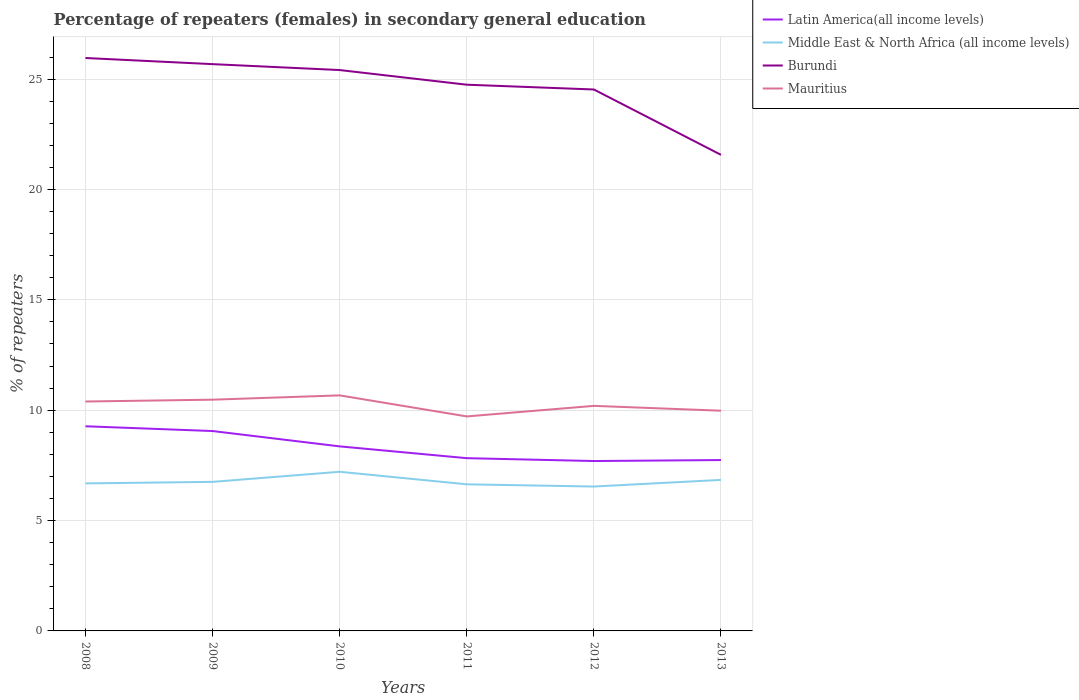Does the line corresponding to Middle East & North Africa (all income levels) intersect with the line corresponding to Latin America(all income levels)?
Offer a terse response. No. Across all years, what is the maximum percentage of female repeaters in Mauritius?
Keep it short and to the point. 9.72. What is the total percentage of female repeaters in Middle East & North Africa (all income levels) in the graph?
Provide a short and direct response. -0.53. What is the difference between the highest and the second highest percentage of female repeaters in Burundi?
Provide a short and direct response. 4.39. Is the percentage of female repeaters in Burundi strictly greater than the percentage of female repeaters in Mauritius over the years?
Your answer should be compact. No. How many lines are there?
Offer a very short reply. 4. What is the difference between two consecutive major ticks on the Y-axis?
Your response must be concise. 5. Are the values on the major ticks of Y-axis written in scientific E-notation?
Provide a succinct answer. No. Where does the legend appear in the graph?
Your response must be concise. Top right. How are the legend labels stacked?
Provide a succinct answer. Vertical. What is the title of the graph?
Offer a very short reply. Percentage of repeaters (females) in secondary general education. Does "Cote d'Ivoire" appear as one of the legend labels in the graph?
Make the answer very short. No. What is the label or title of the X-axis?
Make the answer very short. Years. What is the label or title of the Y-axis?
Make the answer very short. % of repeaters. What is the % of repeaters in Latin America(all income levels) in 2008?
Give a very brief answer. 9.27. What is the % of repeaters of Middle East & North Africa (all income levels) in 2008?
Your response must be concise. 6.68. What is the % of repeaters of Burundi in 2008?
Ensure brevity in your answer.  25.96. What is the % of repeaters in Mauritius in 2008?
Offer a terse response. 10.39. What is the % of repeaters in Latin America(all income levels) in 2009?
Ensure brevity in your answer.  9.06. What is the % of repeaters of Middle East & North Africa (all income levels) in 2009?
Offer a terse response. 6.75. What is the % of repeaters in Burundi in 2009?
Offer a terse response. 25.68. What is the % of repeaters in Mauritius in 2009?
Ensure brevity in your answer.  10.48. What is the % of repeaters in Latin America(all income levels) in 2010?
Provide a succinct answer. 8.36. What is the % of repeaters in Middle East & North Africa (all income levels) in 2010?
Provide a succinct answer. 7.21. What is the % of repeaters of Burundi in 2010?
Make the answer very short. 25.41. What is the % of repeaters in Mauritius in 2010?
Offer a very short reply. 10.67. What is the % of repeaters in Latin America(all income levels) in 2011?
Give a very brief answer. 7.83. What is the % of repeaters of Middle East & North Africa (all income levels) in 2011?
Your answer should be compact. 6.64. What is the % of repeaters in Burundi in 2011?
Give a very brief answer. 24.75. What is the % of repeaters of Mauritius in 2011?
Offer a terse response. 9.72. What is the % of repeaters of Latin America(all income levels) in 2012?
Offer a very short reply. 7.7. What is the % of repeaters in Middle East & North Africa (all income levels) in 2012?
Provide a succinct answer. 6.54. What is the % of repeaters of Burundi in 2012?
Your answer should be compact. 24.53. What is the % of repeaters in Mauritius in 2012?
Your answer should be compact. 10.2. What is the % of repeaters of Latin America(all income levels) in 2013?
Ensure brevity in your answer.  7.74. What is the % of repeaters of Middle East & North Africa (all income levels) in 2013?
Provide a succinct answer. 6.84. What is the % of repeaters in Burundi in 2013?
Make the answer very short. 21.57. What is the % of repeaters in Mauritius in 2013?
Offer a terse response. 9.98. Across all years, what is the maximum % of repeaters of Latin America(all income levels)?
Your response must be concise. 9.27. Across all years, what is the maximum % of repeaters of Middle East & North Africa (all income levels)?
Give a very brief answer. 7.21. Across all years, what is the maximum % of repeaters in Burundi?
Offer a very short reply. 25.96. Across all years, what is the maximum % of repeaters of Mauritius?
Keep it short and to the point. 10.67. Across all years, what is the minimum % of repeaters in Latin America(all income levels)?
Your response must be concise. 7.7. Across all years, what is the minimum % of repeaters of Middle East & North Africa (all income levels)?
Your answer should be compact. 6.54. Across all years, what is the minimum % of repeaters of Burundi?
Make the answer very short. 21.57. Across all years, what is the minimum % of repeaters of Mauritius?
Offer a terse response. 9.72. What is the total % of repeaters in Latin America(all income levels) in the graph?
Offer a terse response. 49.96. What is the total % of repeaters of Middle East & North Africa (all income levels) in the graph?
Ensure brevity in your answer.  40.68. What is the total % of repeaters in Burundi in the graph?
Provide a succinct answer. 147.9. What is the total % of repeaters in Mauritius in the graph?
Ensure brevity in your answer.  61.44. What is the difference between the % of repeaters of Latin America(all income levels) in 2008 and that in 2009?
Offer a very short reply. 0.22. What is the difference between the % of repeaters of Middle East & North Africa (all income levels) in 2008 and that in 2009?
Give a very brief answer. -0.07. What is the difference between the % of repeaters in Burundi in 2008 and that in 2009?
Offer a terse response. 0.28. What is the difference between the % of repeaters in Mauritius in 2008 and that in 2009?
Keep it short and to the point. -0.08. What is the difference between the % of repeaters of Latin America(all income levels) in 2008 and that in 2010?
Make the answer very short. 0.91. What is the difference between the % of repeaters in Middle East & North Africa (all income levels) in 2008 and that in 2010?
Offer a very short reply. -0.53. What is the difference between the % of repeaters in Burundi in 2008 and that in 2010?
Your answer should be very brief. 0.55. What is the difference between the % of repeaters in Mauritius in 2008 and that in 2010?
Your answer should be very brief. -0.28. What is the difference between the % of repeaters in Latin America(all income levels) in 2008 and that in 2011?
Provide a succinct answer. 1.45. What is the difference between the % of repeaters of Middle East & North Africa (all income levels) in 2008 and that in 2011?
Your answer should be compact. 0.04. What is the difference between the % of repeaters of Burundi in 2008 and that in 2011?
Make the answer very short. 1.21. What is the difference between the % of repeaters of Mauritius in 2008 and that in 2011?
Your answer should be compact. 0.68. What is the difference between the % of repeaters of Latin America(all income levels) in 2008 and that in 2012?
Your answer should be compact. 1.57. What is the difference between the % of repeaters of Middle East & North Africa (all income levels) in 2008 and that in 2012?
Keep it short and to the point. 0.14. What is the difference between the % of repeaters in Burundi in 2008 and that in 2012?
Offer a very short reply. 1.43. What is the difference between the % of repeaters of Mauritius in 2008 and that in 2012?
Offer a terse response. 0.2. What is the difference between the % of repeaters in Latin America(all income levels) in 2008 and that in 2013?
Ensure brevity in your answer.  1.53. What is the difference between the % of repeaters in Middle East & North Africa (all income levels) in 2008 and that in 2013?
Offer a terse response. -0.16. What is the difference between the % of repeaters of Burundi in 2008 and that in 2013?
Offer a very short reply. 4.39. What is the difference between the % of repeaters in Mauritius in 2008 and that in 2013?
Make the answer very short. 0.42. What is the difference between the % of repeaters in Latin America(all income levels) in 2009 and that in 2010?
Make the answer very short. 0.69. What is the difference between the % of repeaters in Middle East & North Africa (all income levels) in 2009 and that in 2010?
Your answer should be very brief. -0.46. What is the difference between the % of repeaters of Burundi in 2009 and that in 2010?
Give a very brief answer. 0.27. What is the difference between the % of repeaters in Mauritius in 2009 and that in 2010?
Offer a very short reply. -0.19. What is the difference between the % of repeaters of Latin America(all income levels) in 2009 and that in 2011?
Give a very brief answer. 1.23. What is the difference between the % of repeaters of Middle East & North Africa (all income levels) in 2009 and that in 2011?
Ensure brevity in your answer.  0.11. What is the difference between the % of repeaters in Burundi in 2009 and that in 2011?
Offer a very short reply. 0.93. What is the difference between the % of repeaters of Mauritius in 2009 and that in 2011?
Provide a short and direct response. 0.76. What is the difference between the % of repeaters of Latin America(all income levels) in 2009 and that in 2012?
Offer a terse response. 1.36. What is the difference between the % of repeaters of Middle East & North Africa (all income levels) in 2009 and that in 2012?
Your answer should be compact. 0.21. What is the difference between the % of repeaters in Burundi in 2009 and that in 2012?
Make the answer very short. 1.15. What is the difference between the % of repeaters of Mauritius in 2009 and that in 2012?
Your answer should be compact. 0.28. What is the difference between the % of repeaters of Latin America(all income levels) in 2009 and that in 2013?
Make the answer very short. 1.31. What is the difference between the % of repeaters of Middle East & North Africa (all income levels) in 2009 and that in 2013?
Provide a short and direct response. -0.09. What is the difference between the % of repeaters in Burundi in 2009 and that in 2013?
Provide a succinct answer. 4.11. What is the difference between the % of repeaters of Mauritius in 2009 and that in 2013?
Give a very brief answer. 0.5. What is the difference between the % of repeaters of Latin America(all income levels) in 2010 and that in 2011?
Make the answer very short. 0.53. What is the difference between the % of repeaters of Middle East & North Africa (all income levels) in 2010 and that in 2011?
Ensure brevity in your answer.  0.57. What is the difference between the % of repeaters in Burundi in 2010 and that in 2011?
Your answer should be very brief. 0.66. What is the difference between the % of repeaters in Mauritius in 2010 and that in 2011?
Your response must be concise. 0.95. What is the difference between the % of repeaters in Latin America(all income levels) in 2010 and that in 2012?
Provide a succinct answer. 0.66. What is the difference between the % of repeaters in Middle East & North Africa (all income levels) in 2010 and that in 2012?
Your answer should be compact. 0.67. What is the difference between the % of repeaters in Burundi in 2010 and that in 2012?
Ensure brevity in your answer.  0.88. What is the difference between the % of repeaters of Mauritius in 2010 and that in 2012?
Make the answer very short. 0.48. What is the difference between the % of repeaters of Latin America(all income levels) in 2010 and that in 2013?
Your answer should be compact. 0.62. What is the difference between the % of repeaters in Middle East & North Africa (all income levels) in 2010 and that in 2013?
Provide a short and direct response. 0.37. What is the difference between the % of repeaters of Burundi in 2010 and that in 2013?
Offer a very short reply. 3.84. What is the difference between the % of repeaters of Mauritius in 2010 and that in 2013?
Keep it short and to the point. 0.69. What is the difference between the % of repeaters in Latin America(all income levels) in 2011 and that in 2012?
Offer a very short reply. 0.13. What is the difference between the % of repeaters in Middle East & North Africa (all income levels) in 2011 and that in 2012?
Offer a very short reply. 0.1. What is the difference between the % of repeaters of Burundi in 2011 and that in 2012?
Ensure brevity in your answer.  0.22. What is the difference between the % of repeaters of Mauritius in 2011 and that in 2012?
Keep it short and to the point. -0.48. What is the difference between the % of repeaters of Latin America(all income levels) in 2011 and that in 2013?
Provide a short and direct response. 0.08. What is the difference between the % of repeaters of Middle East & North Africa (all income levels) in 2011 and that in 2013?
Give a very brief answer. -0.2. What is the difference between the % of repeaters of Burundi in 2011 and that in 2013?
Offer a very short reply. 3.18. What is the difference between the % of repeaters in Mauritius in 2011 and that in 2013?
Provide a short and direct response. -0.26. What is the difference between the % of repeaters of Latin America(all income levels) in 2012 and that in 2013?
Give a very brief answer. -0.04. What is the difference between the % of repeaters in Middle East & North Africa (all income levels) in 2012 and that in 2013?
Keep it short and to the point. -0.3. What is the difference between the % of repeaters of Burundi in 2012 and that in 2013?
Offer a terse response. 2.96. What is the difference between the % of repeaters in Mauritius in 2012 and that in 2013?
Your response must be concise. 0.22. What is the difference between the % of repeaters in Latin America(all income levels) in 2008 and the % of repeaters in Middle East & North Africa (all income levels) in 2009?
Provide a succinct answer. 2.52. What is the difference between the % of repeaters of Latin America(all income levels) in 2008 and the % of repeaters of Burundi in 2009?
Offer a terse response. -16.41. What is the difference between the % of repeaters of Latin America(all income levels) in 2008 and the % of repeaters of Mauritius in 2009?
Your response must be concise. -1.2. What is the difference between the % of repeaters of Middle East & North Africa (all income levels) in 2008 and the % of repeaters of Burundi in 2009?
Provide a succinct answer. -19. What is the difference between the % of repeaters of Middle East & North Africa (all income levels) in 2008 and the % of repeaters of Mauritius in 2009?
Make the answer very short. -3.79. What is the difference between the % of repeaters in Burundi in 2008 and the % of repeaters in Mauritius in 2009?
Offer a terse response. 15.48. What is the difference between the % of repeaters of Latin America(all income levels) in 2008 and the % of repeaters of Middle East & North Africa (all income levels) in 2010?
Provide a succinct answer. 2.06. What is the difference between the % of repeaters in Latin America(all income levels) in 2008 and the % of repeaters in Burundi in 2010?
Your answer should be compact. -16.14. What is the difference between the % of repeaters of Latin America(all income levels) in 2008 and the % of repeaters of Mauritius in 2010?
Provide a short and direct response. -1.4. What is the difference between the % of repeaters in Middle East & North Africa (all income levels) in 2008 and the % of repeaters in Burundi in 2010?
Your answer should be very brief. -18.73. What is the difference between the % of repeaters of Middle East & North Africa (all income levels) in 2008 and the % of repeaters of Mauritius in 2010?
Your response must be concise. -3.99. What is the difference between the % of repeaters in Burundi in 2008 and the % of repeaters in Mauritius in 2010?
Make the answer very short. 15.29. What is the difference between the % of repeaters of Latin America(all income levels) in 2008 and the % of repeaters of Middle East & North Africa (all income levels) in 2011?
Your answer should be compact. 2.63. What is the difference between the % of repeaters of Latin America(all income levels) in 2008 and the % of repeaters of Burundi in 2011?
Your answer should be very brief. -15.48. What is the difference between the % of repeaters of Latin America(all income levels) in 2008 and the % of repeaters of Mauritius in 2011?
Keep it short and to the point. -0.45. What is the difference between the % of repeaters of Middle East & North Africa (all income levels) in 2008 and the % of repeaters of Burundi in 2011?
Provide a succinct answer. -18.06. What is the difference between the % of repeaters in Middle East & North Africa (all income levels) in 2008 and the % of repeaters in Mauritius in 2011?
Provide a short and direct response. -3.04. What is the difference between the % of repeaters of Burundi in 2008 and the % of repeaters of Mauritius in 2011?
Your answer should be very brief. 16.24. What is the difference between the % of repeaters of Latin America(all income levels) in 2008 and the % of repeaters of Middle East & North Africa (all income levels) in 2012?
Offer a terse response. 2.73. What is the difference between the % of repeaters in Latin America(all income levels) in 2008 and the % of repeaters in Burundi in 2012?
Make the answer very short. -15.26. What is the difference between the % of repeaters in Latin America(all income levels) in 2008 and the % of repeaters in Mauritius in 2012?
Offer a very short reply. -0.92. What is the difference between the % of repeaters of Middle East & North Africa (all income levels) in 2008 and the % of repeaters of Burundi in 2012?
Provide a succinct answer. -17.85. What is the difference between the % of repeaters of Middle East & North Africa (all income levels) in 2008 and the % of repeaters of Mauritius in 2012?
Provide a succinct answer. -3.51. What is the difference between the % of repeaters in Burundi in 2008 and the % of repeaters in Mauritius in 2012?
Your response must be concise. 15.76. What is the difference between the % of repeaters in Latin America(all income levels) in 2008 and the % of repeaters in Middle East & North Africa (all income levels) in 2013?
Offer a terse response. 2.43. What is the difference between the % of repeaters in Latin America(all income levels) in 2008 and the % of repeaters in Burundi in 2013?
Your response must be concise. -12.3. What is the difference between the % of repeaters of Latin America(all income levels) in 2008 and the % of repeaters of Mauritius in 2013?
Provide a short and direct response. -0.71. What is the difference between the % of repeaters of Middle East & North Africa (all income levels) in 2008 and the % of repeaters of Burundi in 2013?
Your answer should be very brief. -14.89. What is the difference between the % of repeaters of Middle East & North Africa (all income levels) in 2008 and the % of repeaters of Mauritius in 2013?
Your response must be concise. -3.29. What is the difference between the % of repeaters of Burundi in 2008 and the % of repeaters of Mauritius in 2013?
Your answer should be compact. 15.98. What is the difference between the % of repeaters in Latin America(all income levels) in 2009 and the % of repeaters in Middle East & North Africa (all income levels) in 2010?
Give a very brief answer. 1.85. What is the difference between the % of repeaters of Latin America(all income levels) in 2009 and the % of repeaters of Burundi in 2010?
Your answer should be compact. -16.36. What is the difference between the % of repeaters of Latin America(all income levels) in 2009 and the % of repeaters of Mauritius in 2010?
Provide a succinct answer. -1.62. What is the difference between the % of repeaters of Middle East & North Africa (all income levels) in 2009 and the % of repeaters of Burundi in 2010?
Make the answer very short. -18.66. What is the difference between the % of repeaters of Middle East & North Africa (all income levels) in 2009 and the % of repeaters of Mauritius in 2010?
Your answer should be compact. -3.92. What is the difference between the % of repeaters of Burundi in 2009 and the % of repeaters of Mauritius in 2010?
Offer a very short reply. 15.01. What is the difference between the % of repeaters of Latin America(all income levels) in 2009 and the % of repeaters of Middle East & North Africa (all income levels) in 2011?
Make the answer very short. 2.41. What is the difference between the % of repeaters in Latin America(all income levels) in 2009 and the % of repeaters in Burundi in 2011?
Ensure brevity in your answer.  -15.69. What is the difference between the % of repeaters in Latin America(all income levels) in 2009 and the % of repeaters in Mauritius in 2011?
Provide a short and direct response. -0.66. What is the difference between the % of repeaters of Middle East & North Africa (all income levels) in 2009 and the % of repeaters of Burundi in 2011?
Make the answer very short. -17.99. What is the difference between the % of repeaters of Middle East & North Africa (all income levels) in 2009 and the % of repeaters of Mauritius in 2011?
Provide a succinct answer. -2.96. What is the difference between the % of repeaters of Burundi in 2009 and the % of repeaters of Mauritius in 2011?
Offer a terse response. 15.96. What is the difference between the % of repeaters in Latin America(all income levels) in 2009 and the % of repeaters in Middle East & North Africa (all income levels) in 2012?
Keep it short and to the point. 2.51. What is the difference between the % of repeaters of Latin America(all income levels) in 2009 and the % of repeaters of Burundi in 2012?
Your answer should be very brief. -15.48. What is the difference between the % of repeaters in Latin America(all income levels) in 2009 and the % of repeaters in Mauritius in 2012?
Your answer should be compact. -1.14. What is the difference between the % of repeaters in Middle East & North Africa (all income levels) in 2009 and the % of repeaters in Burundi in 2012?
Your answer should be very brief. -17.78. What is the difference between the % of repeaters of Middle East & North Africa (all income levels) in 2009 and the % of repeaters of Mauritius in 2012?
Your answer should be compact. -3.44. What is the difference between the % of repeaters in Burundi in 2009 and the % of repeaters in Mauritius in 2012?
Provide a short and direct response. 15.48. What is the difference between the % of repeaters in Latin America(all income levels) in 2009 and the % of repeaters in Middle East & North Africa (all income levels) in 2013?
Your answer should be very brief. 2.21. What is the difference between the % of repeaters of Latin America(all income levels) in 2009 and the % of repeaters of Burundi in 2013?
Offer a terse response. -12.51. What is the difference between the % of repeaters of Latin America(all income levels) in 2009 and the % of repeaters of Mauritius in 2013?
Make the answer very short. -0.92. What is the difference between the % of repeaters of Middle East & North Africa (all income levels) in 2009 and the % of repeaters of Burundi in 2013?
Give a very brief answer. -14.82. What is the difference between the % of repeaters of Middle East & North Africa (all income levels) in 2009 and the % of repeaters of Mauritius in 2013?
Keep it short and to the point. -3.22. What is the difference between the % of repeaters in Burundi in 2009 and the % of repeaters in Mauritius in 2013?
Keep it short and to the point. 15.7. What is the difference between the % of repeaters of Latin America(all income levels) in 2010 and the % of repeaters of Middle East & North Africa (all income levels) in 2011?
Your answer should be very brief. 1.72. What is the difference between the % of repeaters in Latin America(all income levels) in 2010 and the % of repeaters in Burundi in 2011?
Provide a short and direct response. -16.39. What is the difference between the % of repeaters of Latin America(all income levels) in 2010 and the % of repeaters of Mauritius in 2011?
Make the answer very short. -1.36. What is the difference between the % of repeaters in Middle East & North Africa (all income levels) in 2010 and the % of repeaters in Burundi in 2011?
Your response must be concise. -17.54. What is the difference between the % of repeaters in Middle East & North Africa (all income levels) in 2010 and the % of repeaters in Mauritius in 2011?
Provide a short and direct response. -2.51. What is the difference between the % of repeaters of Burundi in 2010 and the % of repeaters of Mauritius in 2011?
Your answer should be compact. 15.69. What is the difference between the % of repeaters of Latin America(all income levels) in 2010 and the % of repeaters of Middle East & North Africa (all income levels) in 2012?
Make the answer very short. 1.82. What is the difference between the % of repeaters in Latin America(all income levels) in 2010 and the % of repeaters in Burundi in 2012?
Provide a short and direct response. -16.17. What is the difference between the % of repeaters in Latin America(all income levels) in 2010 and the % of repeaters in Mauritius in 2012?
Provide a succinct answer. -1.84. What is the difference between the % of repeaters of Middle East & North Africa (all income levels) in 2010 and the % of repeaters of Burundi in 2012?
Provide a short and direct response. -17.32. What is the difference between the % of repeaters in Middle East & North Africa (all income levels) in 2010 and the % of repeaters in Mauritius in 2012?
Provide a short and direct response. -2.99. What is the difference between the % of repeaters of Burundi in 2010 and the % of repeaters of Mauritius in 2012?
Your answer should be compact. 15.22. What is the difference between the % of repeaters in Latin America(all income levels) in 2010 and the % of repeaters in Middle East & North Africa (all income levels) in 2013?
Offer a very short reply. 1.52. What is the difference between the % of repeaters of Latin America(all income levels) in 2010 and the % of repeaters of Burundi in 2013?
Your answer should be compact. -13.21. What is the difference between the % of repeaters in Latin America(all income levels) in 2010 and the % of repeaters in Mauritius in 2013?
Provide a succinct answer. -1.62. What is the difference between the % of repeaters of Middle East & North Africa (all income levels) in 2010 and the % of repeaters of Burundi in 2013?
Offer a terse response. -14.36. What is the difference between the % of repeaters in Middle East & North Africa (all income levels) in 2010 and the % of repeaters in Mauritius in 2013?
Keep it short and to the point. -2.77. What is the difference between the % of repeaters of Burundi in 2010 and the % of repeaters of Mauritius in 2013?
Ensure brevity in your answer.  15.43. What is the difference between the % of repeaters of Latin America(all income levels) in 2011 and the % of repeaters of Middle East & North Africa (all income levels) in 2012?
Keep it short and to the point. 1.28. What is the difference between the % of repeaters of Latin America(all income levels) in 2011 and the % of repeaters of Burundi in 2012?
Your answer should be compact. -16.7. What is the difference between the % of repeaters in Latin America(all income levels) in 2011 and the % of repeaters in Mauritius in 2012?
Your answer should be compact. -2.37. What is the difference between the % of repeaters of Middle East & North Africa (all income levels) in 2011 and the % of repeaters of Burundi in 2012?
Keep it short and to the point. -17.89. What is the difference between the % of repeaters in Middle East & North Africa (all income levels) in 2011 and the % of repeaters in Mauritius in 2012?
Offer a terse response. -3.55. What is the difference between the % of repeaters in Burundi in 2011 and the % of repeaters in Mauritius in 2012?
Provide a succinct answer. 14.55. What is the difference between the % of repeaters in Latin America(all income levels) in 2011 and the % of repeaters in Middle East & North Africa (all income levels) in 2013?
Offer a very short reply. 0.98. What is the difference between the % of repeaters of Latin America(all income levels) in 2011 and the % of repeaters of Burundi in 2013?
Your response must be concise. -13.74. What is the difference between the % of repeaters of Latin America(all income levels) in 2011 and the % of repeaters of Mauritius in 2013?
Offer a terse response. -2.15. What is the difference between the % of repeaters of Middle East & North Africa (all income levels) in 2011 and the % of repeaters of Burundi in 2013?
Your answer should be very brief. -14.93. What is the difference between the % of repeaters in Middle East & North Africa (all income levels) in 2011 and the % of repeaters in Mauritius in 2013?
Your response must be concise. -3.34. What is the difference between the % of repeaters in Burundi in 2011 and the % of repeaters in Mauritius in 2013?
Give a very brief answer. 14.77. What is the difference between the % of repeaters of Latin America(all income levels) in 2012 and the % of repeaters of Middle East & North Africa (all income levels) in 2013?
Keep it short and to the point. 0.85. What is the difference between the % of repeaters in Latin America(all income levels) in 2012 and the % of repeaters in Burundi in 2013?
Provide a succinct answer. -13.87. What is the difference between the % of repeaters in Latin America(all income levels) in 2012 and the % of repeaters in Mauritius in 2013?
Provide a succinct answer. -2.28. What is the difference between the % of repeaters in Middle East & North Africa (all income levels) in 2012 and the % of repeaters in Burundi in 2013?
Provide a succinct answer. -15.03. What is the difference between the % of repeaters in Middle East & North Africa (all income levels) in 2012 and the % of repeaters in Mauritius in 2013?
Your response must be concise. -3.44. What is the difference between the % of repeaters of Burundi in 2012 and the % of repeaters of Mauritius in 2013?
Offer a terse response. 14.55. What is the average % of repeaters in Latin America(all income levels) per year?
Ensure brevity in your answer.  8.33. What is the average % of repeaters in Middle East & North Africa (all income levels) per year?
Your answer should be very brief. 6.78. What is the average % of repeaters in Burundi per year?
Your response must be concise. 24.65. What is the average % of repeaters in Mauritius per year?
Keep it short and to the point. 10.24. In the year 2008, what is the difference between the % of repeaters in Latin America(all income levels) and % of repeaters in Middle East & North Africa (all income levels)?
Offer a terse response. 2.59. In the year 2008, what is the difference between the % of repeaters of Latin America(all income levels) and % of repeaters of Burundi?
Make the answer very short. -16.69. In the year 2008, what is the difference between the % of repeaters of Latin America(all income levels) and % of repeaters of Mauritius?
Keep it short and to the point. -1.12. In the year 2008, what is the difference between the % of repeaters of Middle East & North Africa (all income levels) and % of repeaters of Burundi?
Offer a terse response. -19.27. In the year 2008, what is the difference between the % of repeaters in Middle East & North Africa (all income levels) and % of repeaters in Mauritius?
Make the answer very short. -3.71. In the year 2008, what is the difference between the % of repeaters of Burundi and % of repeaters of Mauritius?
Provide a succinct answer. 15.56. In the year 2009, what is the difference between the % of repeaters in Latin America(all income levels) and % of repeaters in Middle East & North Africa (all income levels)?
Offer a terse response. 2.3. In the year 2009, what is the difference between the % of repeaters in Latin America(all income levels) and % of repeaters in Burundi?
Your answer should be very brief. -16.62. In the year 2009, what is the difference between the % of repeaters of Latin America(all income levels) and % of repeaters of Mauritius?
Offer a terse response. -1.42. In the year 2009, what is the difference between the % of repeaters in Middle East & North Africa (all income levels) and % of repeaters in Burundi?
Provide a short and direct response. -18.93. In the year 2009, what is the difference between the % of repeaters of Middle East & North Africa (all income levels) and % of repeaters of Mauritius?
Your response must be concise. -3.72. In the year 2009, what is the difference between the % of repeaters in Burundi and % of repeaters in Mauritius?
Your answer should be compact. 15.2. In the year 2010, what is the difference between the % of repeaters in Latin America(all income levels) and % of repeaters in Middle East & North Africa (all income levels)?
Offer a very short reply. 1.15. In the year 2010, what is the difference between the % of repeaters in Latin America(all income levels) and % of repeaters in Burundi?
Ensure brevity in your answer.  -17.05. In the year 2010, what is the difference between the % of repeaters of Latin America(all income levels) and % of repeaters of Mauritius?
Offer a terse response. -2.31. In the year 2010, what is the difference between the % of repeaters in Middle East & North Africa (all income levels) and % of repeaters in Burundi?
Give a very brief answer. -18.2. In the year 2010, what is the difference between the % of repeaters in Middle East & North Africa (all income levels) and % of repeaters in Mauritius?
Your answer should be very brief. -3.46. In the year 2010, what is the difference between the % of repeaters in Burundi and % of repeaters in Mauritius?
Offer a very short reply. 14.74. In the year 2011, what is the difference between the % of repeaters of Latin America(all income levels) and % of repeaters of Middle East & North Africa (all income levels)?
Offer a terse response. 1.19. In the year 2011, what is the difference between the % of repeaters in Latin America(all income levels) and % of repeaters in Burundi?
Ensure brevity in your answer.  -16.92. In the year 2011, what is the difference between the % of repeaters of Latin America(all income levels) and % of repeaters of Mauritius?
Your response must be concise. -1.89. In the year 2011, what is the difference between the % of repeaters in Middle East & North Africa (all income levels) and % of repeaters in Burundi?
Keep it short and to the point. -18.11. In the year 2011, what is the difference between the % of repeaters of Middle East & North Africa (all income levels) and % of repeaters of Mauritius?
Provide a succinct answer. -3.08. In the year 2011, what is the difference between the % of repeaters in Burundi and % of repeaters in Mauritius?
Your answer should be compact. 15.03. In the year 2012, what is the difference between the % of repeaters in Latin America(all income levels) and % of repeaters in Middle East & North Africa (all income levels)?
Provide a short and direct response. 1.16. In the year 2012, what is the difference between the % of repeaters of Latin America(all income levels) and % of repeaters of Burundi?
Provide a succinct answer. -16.83. In the year 2012, what is the difference between the % of repeaters of Latin America(all income levels) and % of repeaters of Mauritius?
Keep it short and to the point. -2.5. In the year 2012, what is the difference between the % of repeaters of Middle East & North Africa (all income levels) and % of repeaters of Burundi?
Offer a very short reply. -17.99. In the year 2012, what is the difference between the % of repeaters of Middle East & North Africa (all income levels) and % of repeaters of Mauritius?
Your answer should be compact. -3.65. In the year 2012, what is the difference between the % of repeaters of Burundi and % of repeaters of Mauritius?
Keep it short and to the point. 14.33. In the year 2013, what is the difference between the % of repeaters in Latin America(all income levels) and % of repeaters in Middle East & North Africa (all income levels)?
Give a very brief answer. 0.9. In the year 2013, what is the difference between the % of repeaters in Latin America(all income levels) and % of repeaters in Burundi?
Ensure brevity in your answer.  -13.83. In the year 2013, what is the difference between the % of repeaters in Latin America(all income levels) and % of repeaters in Mauritius?
Ensure brevity in your answer.  -2.24. In the year 2013, what is the difference between the % of repeaters in Middle East & North Africa (all income levels) and % of repeaters in Burundi?
Your answer should be very brief. -14.73. In the year 2013, what is the difference between the % of repeaters in Middle East & North Africa (all income levels) and % of repeaters in Mauritius?
Your answer should be compact. -3.13. In the year 2013, what is the difference between the % of repeaters in Burundi and % of repeaters in Mauritius?
Keep it short and to the point. 11.59. What is the ratio of the % of repeaters in Latin America(all income levels) in 2008 to that in 2009?
Your response must be concise. 1.02. What is the ratio of the % of repeaters in Middle East & North Africa (all income levels) in 2008 to that in 2009?
Offer a very short reply. 0.99. What is the ratio of the % of repeaters in Burundi in 2008 to that in 2009?
Offer a very short reply. 1.01. What is the ratio of the % of repeaters in Latin America(all income levels) in 2008 to that in 2010?
Offer a very short reply. 1.11. What is the ratio of the % of repeaters in Middle East & North Africa (all income levels) in 2008 to that in 2010?
Your answer should be very brief. 0.93. What is the ratio of the % of repeaters of Burundi in 2008 to that in 2010?
Your answer should be compact. 1.02. What is the ratio of the % of repeaters in Latin America(all income levels) in 2008 to that in 2011?
Offer a very short reply. 1.18. What is the ratio of the % of repeaters of Burundi in 2008 to that in 2011?
Provide a short and direct response. 1.05. What is the ratio of the % of repeaters of Mauritius in 2008 to that in 2011?
Make the answer very short. 1.07. What is the ratio of the % of repeaters in Latin America(all income levels) in 2008 to that in 2012?
Make the answer very short. 1.2. What is the ratio of the % of repeaters of Middle East & North Africa (all income levels) in 2008 to that in 2012?
Offer a terse response. 1.02. What is the ratio of the % of repeaters of Burundi in 2008 to that in 2012?
Make the answer very short. 1.06. What is the ratio of the % of repeaters in Mauritius in 2008 to that in 2012?
Your response must be concise. 1.02. What is the ratio of the % of repeaters in Latin America(all income levels) in 2008 to that in 2013?
Make the answer very short. 1.2. What is the ratio of the % of repeaters of Middle East & North Africa (all income levels) in 2008 to that in 2013?
Provide a succinct answer. 0.98. What is the ratio of the % of repeaters of Burundi in 2008 to that in 2013?
Keep it short and to the point. 1.2. What is the ratio of the % of repeaters of Mauritius in 2008 to that in 2013?
Provide a short and direct response. 1.04. What is the ratio of the % of repeaters in Latin America(all income levels) in 2009 to that in 2010?
Provide a succinct answer. 1.08. What is the ratio of the % of repeaters of Middle East & North Africa (all income levels) in 2009 to that in 2010?
Your answer should be compact. 0.94. What is the ratio of the % of repeaters in Burundi in 2009 to that in 2010?
Offer a terse response. 1.01. What is the ratio of the % of repeaters of Mauritius in 2009 to that in 2010?
Make the answer very short. 0.98. What is the ratio of the % of repeaters of Latin America(all income levels) in 2009 to that in 2011?
Your response must be concise. 1.16. What is the ratio of the % of repeaters in Middle East & North Africa (all income levels) in 2009 to that in 2011?
Your response must be concise. 1.02. What is the ratio of the % of repeaters of Burundi in 2009 to that in 2011?
Provide a short and direct response. 1.04. What is the ratio of the % of repeaters in Mauritius in 2009 to that in 2011?
Ensure brevity in your answer.  1.08. What is the ratio of the % of repeaters in Latin America(all income levels) in 2009 to that in 2012?
Your answer should be compact. 1.18. What is the ratio of the % of repeaters in Middle East & North Africa (all income levels) in 2009 to that in 2012?
Offer a terse response. 1.03. What is the ratio of the % of repeaters in Burundi in 2009 to that in 2012?
Keep it short and to the point. 1.05. What is the ratio of the % of repeaters in Mauritius in 2009 to that in 2012?
Make the answer very short. 1.03. What is the ratio of the % of repeaters of Latin America(all income levels) in 2009 to that in 2013?
Offer a terse response. 1.17. What is the ratio of the % of repeaters of Middle East & North Africa (all income levels) in 2009 to that in 2013?
Make the answer very short. 0.99. What is the ratio of the % of repeaters in Burundi in 2009 to that in 2013?
Give a very brief answer. 1.19. What is the ratio of the % of repeaters of Latin America(all income levels) in 2010 to that in 2011?
Offer a very short reply. 1.07. What is the ratio of the % of repeaters in Middle East & North Africa (all income levels) in 2010 to that in 2011?
Your answer should be compact. 1.09. What is the ratio of the % of repeaters in Burundi in 2010 to that in 2011?
Provide a short and direct response. 1.03. What is the ratio of the % of repeaters in Mauritius in 2010 to that in 2011?
Your answer should be compact. 1.1. What is the ratio of the % of repeaters of Latin America(all income levels) in 2010 to that in 2012?
Offer a terse response. 1.09. What is the ratio of the % of repeaters in Middle East & North Africa (all income levels) in 2010 to that in 2012?
Give a very brief answer. 1.1. What is the ratio of the % of repeaters in Burundi in 2010 to that in 2012?
Provide a succinct answer. 1.04. What is the ratio of the % of repeaters of Mauritius in 2010 to that in 2012?
Ensure brevity in your answer.  1.05. What is the ratio of the % of repeaters of Middle East & North Africa (all income levels) in 2010 to that in 2013?
Your response must be concise. 1.05. What is the ratio of the % of repeaters in Burundi in 2010 to that in 2013?
Keep it short and to the point. 1.18. What is the ratio of the % of repeaters in Mauritius in 2010 to that in 2013?
Give a very brief answer. 1.07. What is the ratio of the % of repeaters in Latin America(all income levels) in 2011 to that in 2012?
Keep it short and to the point. 1.02. What is the ratio of the % of repeaters of Middle East & North Africa (all income levels) in 2011 to that in 2012?
Provide a succinct answer. 1.02. What is the ratio of the % of repeaters of Burundi in 2011 to that in 2012?
Provide a short and direct response. 1.01. What is the ratio of the % of repeaters of Mauritius in 2011 to that in 2012?
Your response must be concise. 0.95. What is the ratio of the % of repeaters in Middle East & North Africa (all income levels) in 2011 to that in 2013?
Provide a succinct answer. 0.97. What is the ratio of the % of repeaters in Burundi in 2011 to that in 2013?
Keep it short and to the point. 1.15. What is the ratio of the % of repeaters in Middle East & North Africa (all income levels) in 2012 to that in 2013?
Provide a short and direct response. 0.96. What is the ratio of the % of repeaters of Burundi in 2012 to that in 2013?
Offer a very short reply. 1.14. What is the ratio of the % of repeaters of Mauritius in 2012 to that in 2013?
Keep it short and to the point. 1.02. What is the difference between the highest and the second highest % of repeaters of Latin America(all income levels)?
Ensure brevity in your answer.  0.22. What is the difference between the highest and the second highest % of repeaters of Middle East & North Africa (all income levels)?
Provide a short and direct response. 0.37. What is the difference between the highest and the second highest % of repeaters of Burundi?
Make the answer very short. 0.28. What is the difference between the highest and the second highest % of repeaters in Mauritius?
Ensure brevity in your answer.  0.19. What is the difference between the highest and the lowest % of repeaters of Latin America(all income levels)?
Give a very brief answer. 1.57. What is the difference between the highest and the lowest % of repeaters of Middle East & North Africa (all income levels)?
Your answer should be very brief. 0.67. What is the difference between the highest and the lowest % of repeaters in Burundi?
Give a very brief answer. 4.39. What is the difference between the highest and the lowest % of repeaters in Mauritius?
Provide a succinct answer. 0.95. 